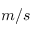Convert formula to latex. <formula><loc_0><loc_0><loc_500><loc_500>m / s</formula> 